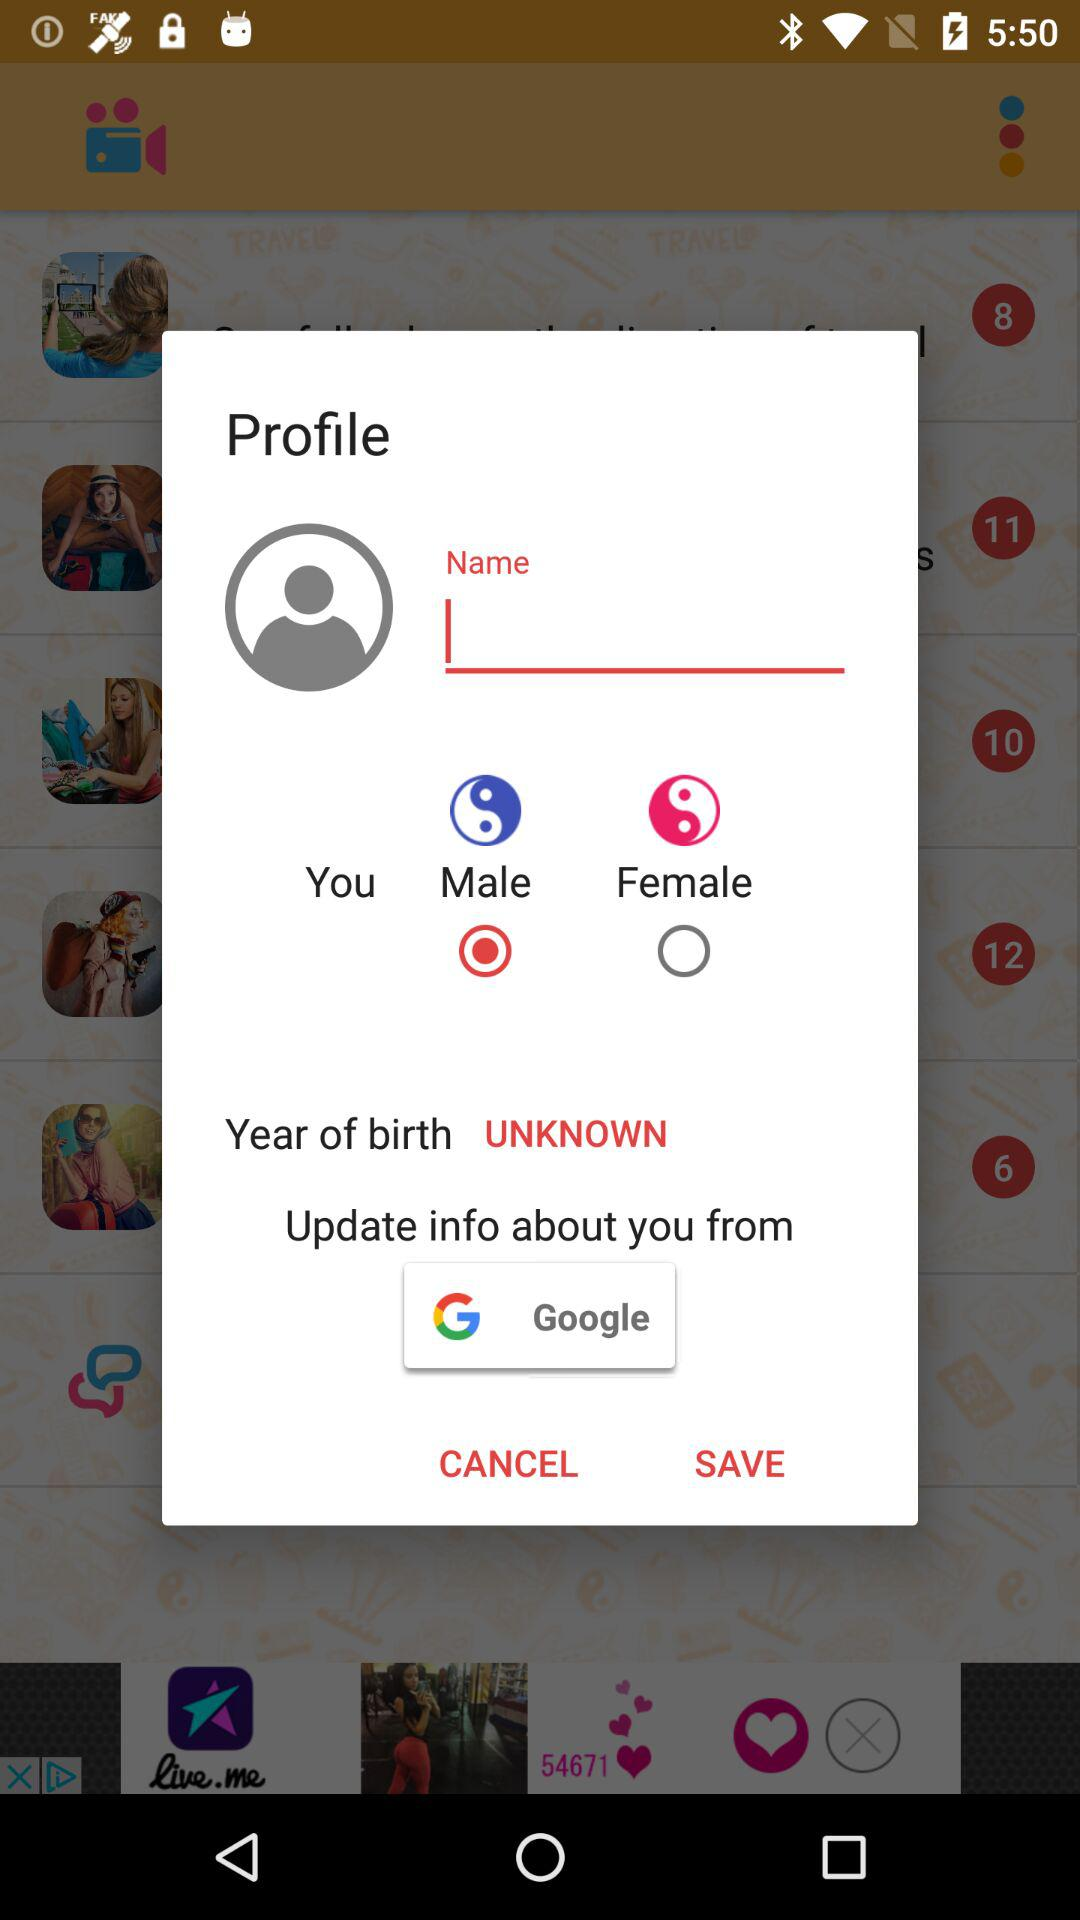From where can the information be updated? The information can be updated from "Google". 